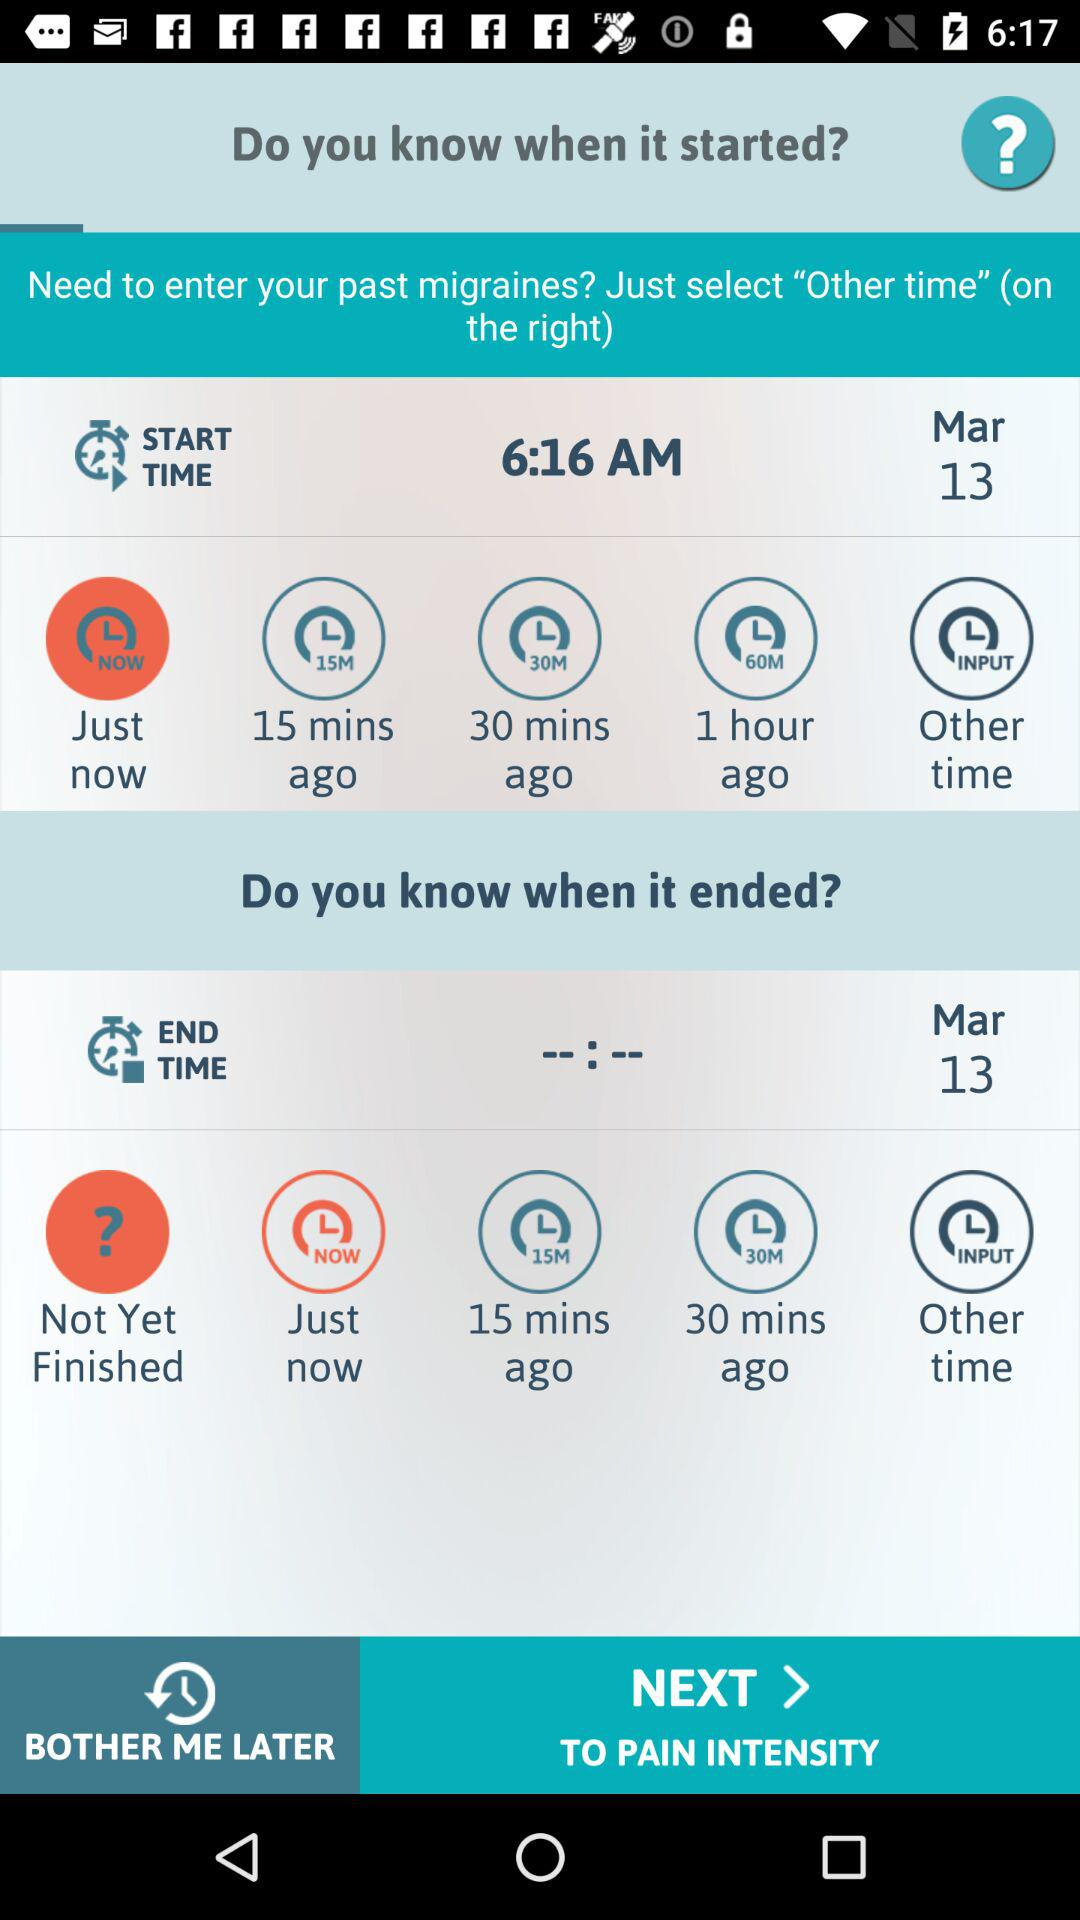What is the start time? The start time is 6:16 a.m. 